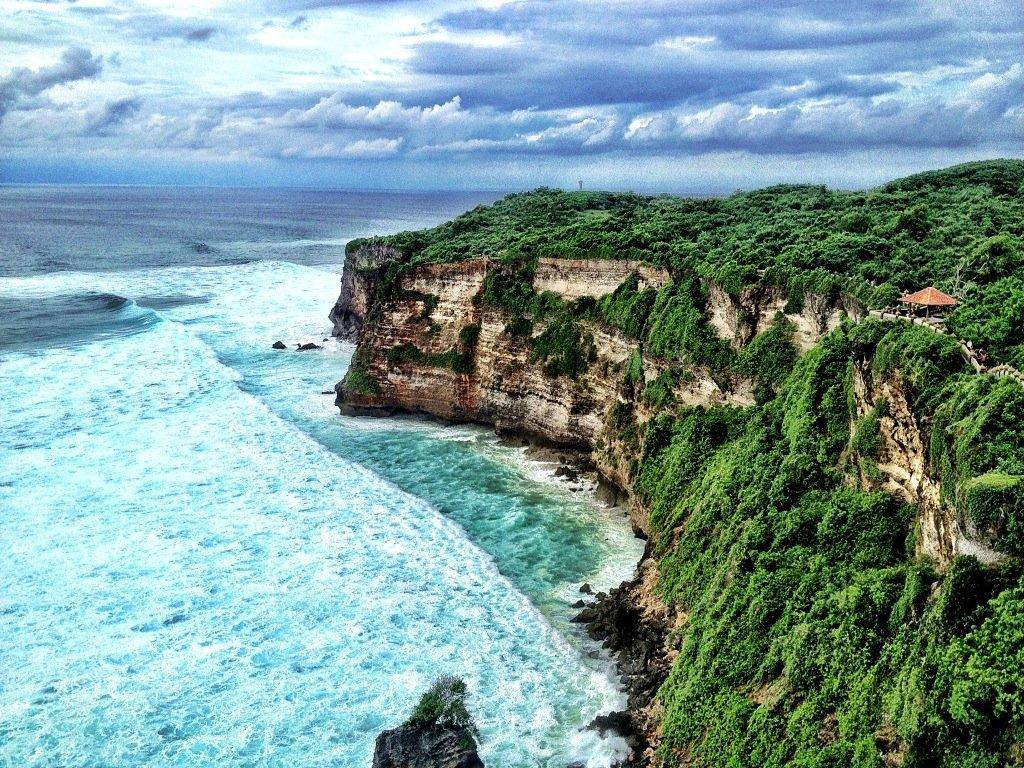What is the setting of the image? The image is an outside view. What can be seen on the right side of the image? There is a hill and many trees on the right side of the image. What is visible on the left side of the image? There is an ocean on the left side of the image. What is visible at the top of the image? The sky is visible at the top of the image. What can be observed in the sky? Clouds are present in the sky. How many stamps are visible on the zebra in the image? There is no zebra present in the image, and therefore no stamps can be observed. What emotion is the image expressing? The image does not express any specific emotion, as it is a landscape scene with a hill, trees, ocean, sky, and clouds. 